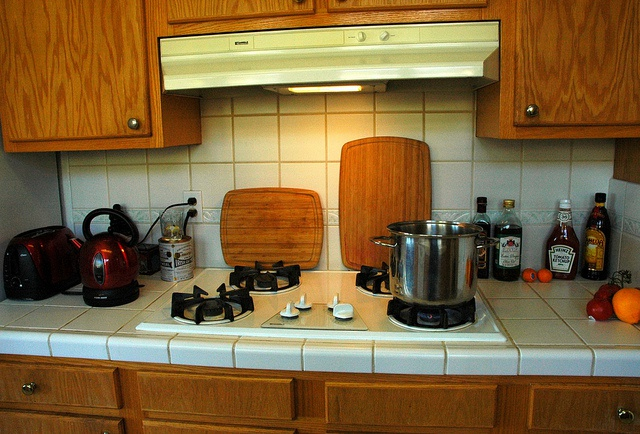Describe the objects in this image and their specific colors. I can see oven in maroon, black, tan, and beige tones, toaster in maroon, black, and purple tones, bottle in maroon, black, and olive tones, bottle in maroon, black, gray, and darkgray tones, and bottle in maroon, black, gray, darkgray, and darkgreen tones in this image. 